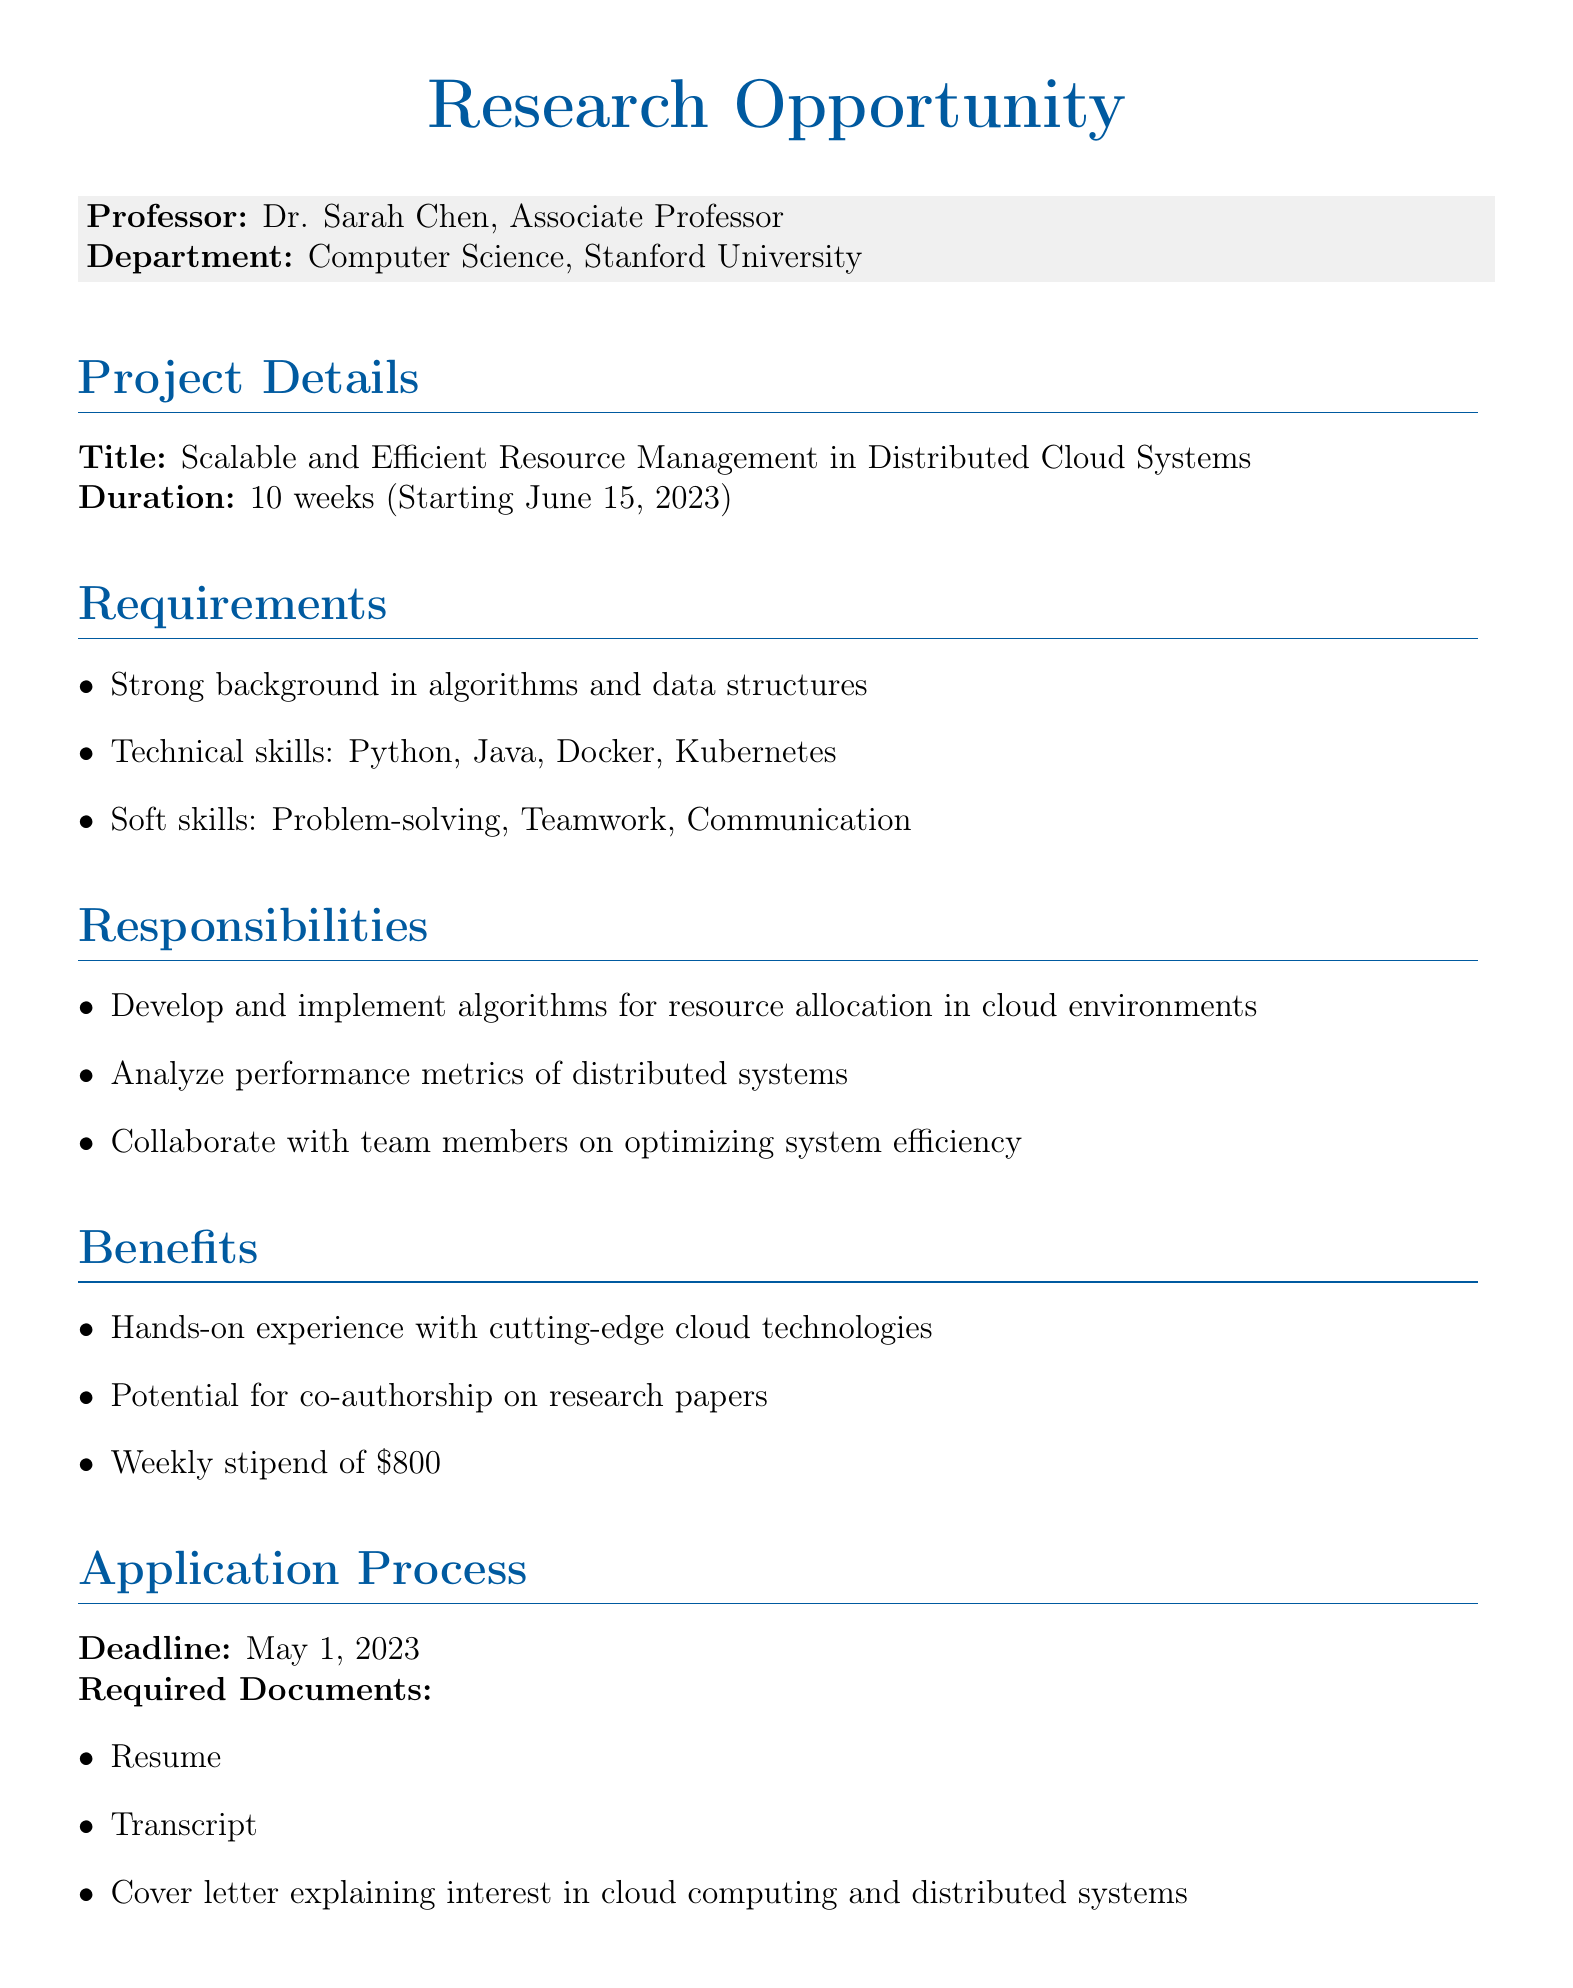What is the professor's name? The professor's name is explicitly stated in the document as Dr. Sarah Chen.
Answer: Dr. Sarah Chen What is the title of the research project? The title of the research project is mentioned clearly in the document as "Scalable and Efficient Resource Management in Distributed Cloud Systems".
Answer: Scalable and Efficient Resource Management in Distributed Cloud Systems When does the research project start? The document specifies that the research project starts on June 15, 2023.
Answer: June 15, 2023 What are the required technical skills? The document lists the required technical skills needed for the project which are Python, Java, Docker, and Kubernetes.
Answer: Python, Java, Docker, Kubernetes What is the weekly stipend for participants? The document states the weekly stipend for participants as $800.
Answer: $800 How long is the duration of the project? The duration of the project is mentioned in the document as 10 weeks.
Answer: 10 weeks What is one of the potential outcomes of participating in this research? The document mentions a potential outcome as a contribution to open-source projects like Apache Hadoop or Apache Spark.
Answer: Contribution to open-source projects like Apache Hadoop or Apache Spark What is the submission method for applications? The document specifies the submission method for applications as emailing to s.chen@cs.stanford.edu.
Answer: Email to s.chen@cs.stanford.edu What is the application deadline? The application deadline is clearly stated in the document as May 1, 2023.
Answer: May 1, 2023 